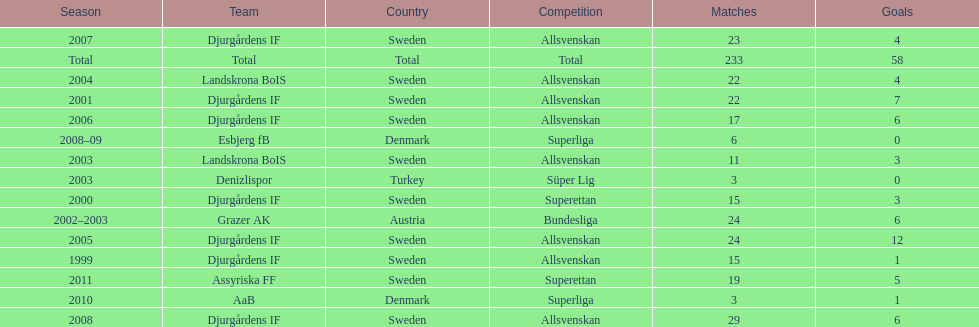What country is team djurgårdens if not from? Sweden. 